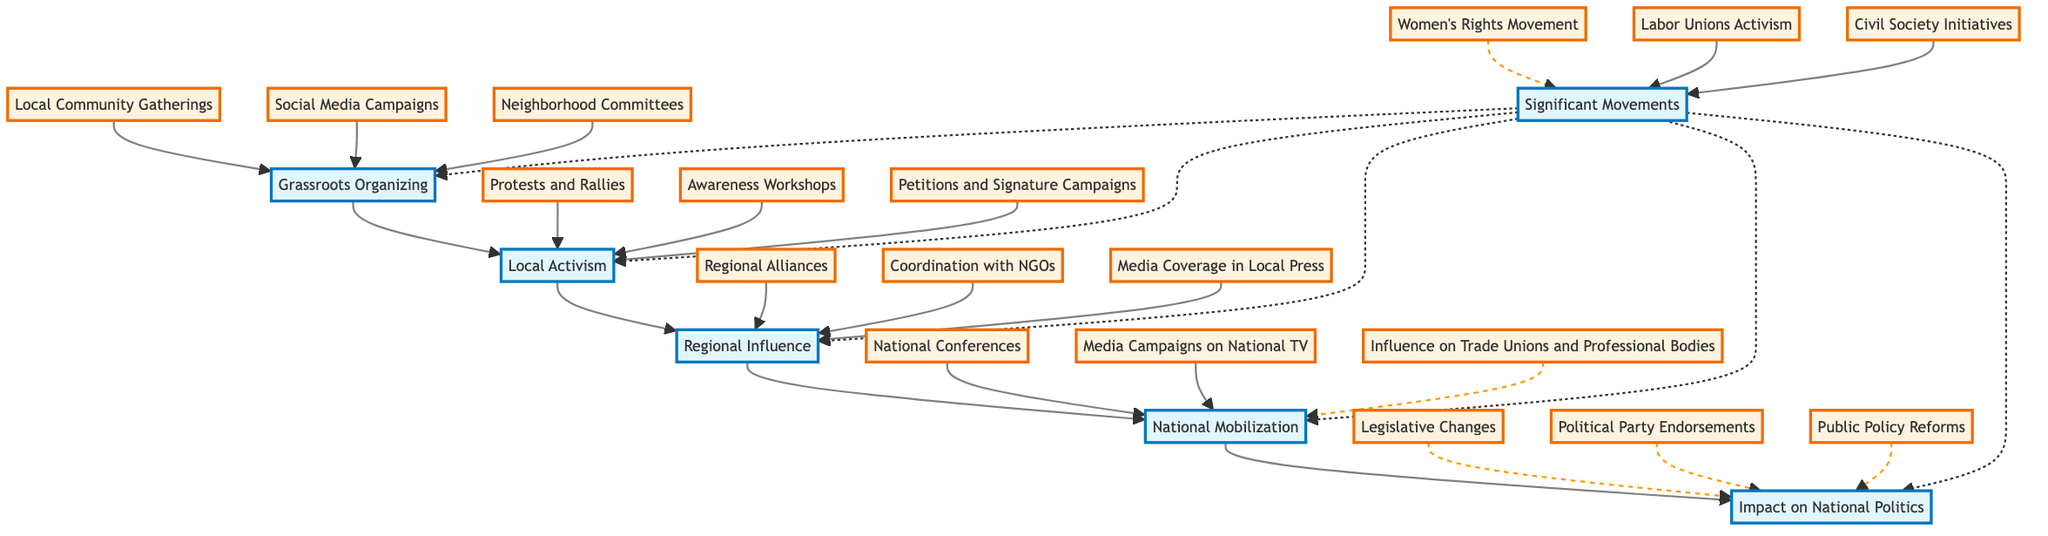What is the starting point of the flow chart? The diagram starts with 'Grassroots Organizing' at the bottom, which serves as the foundational level of the social movements that influence politics in Pakistan.
Answer: Grassroots Organizing How many main nodes are there in the diagram? The diagram has five main nodes: Grassroots Organizing, Local Activism, Regional Influence, National Mobilization, and Impact on National Politics, making a total of five.
Answer: Five What type of movements are shown as significant in the diagram? The significant movements identified in the diagram include the Women's Rights Movement, Labor Unions Activism, and Civil Society Initiatives, showing a focus on social justice and labor issues.
Answer: Women's Rights Movement, Labor Unions Activism, Civil Society Initiatives What does 'National Mobilization' connect to directly above it? 'National Mobilization' connects directly to 'Impact on National Politics', which illustrates that the national-level activities ultimately lead to changes in the political landscape of the country.
Answer: Impact on National Politics Which level precedes 'Regional Influence'? The level that precedes 'Regional Influence' is 'Local Activism', indicating that local efforts are essential before any regional impact can be made.
Answer: Local Activism How many sub-elements does 'Grassroots Organizing' have? 'Grassroots Organizing' has three sub-elements, which are Local Community Gatherings, Social Media Campaigns, and Neighborhood Committees, indicating various methods for grassroots organizing.
Answer: Three Which node contains the phrase 'Legislative Changes'? The node that contains the phrase 'Legislative Changes' is 'Impact on National Politics', suggesting that one of the outcomes of the social movements is the enactment of new laws.
Answer: Impact on National Politics Which significant movement is linked to all levels of the diagram? The 'Women's Rights Movement' is linked to all levels of the diagram, as it represents a movement that influences grassroots to national considerations in Pakistani politics.
Answer: Women's Rights Movement What is the relationship between 'Local Activism' and 'Regional Influence'? 'Local Activism' directly leads to 'Regional Influence', showing that local efforts in activism can expand to affect the broader regional context.
Answer: Leads to What is the final outcome shown in the flow chart? The final outcome illustrated in the flow chart is 'Impact on National Politics', demonstrating that all social movements and organizing levels contribute to political change in the nation.
Answer: Impact on National Politics 